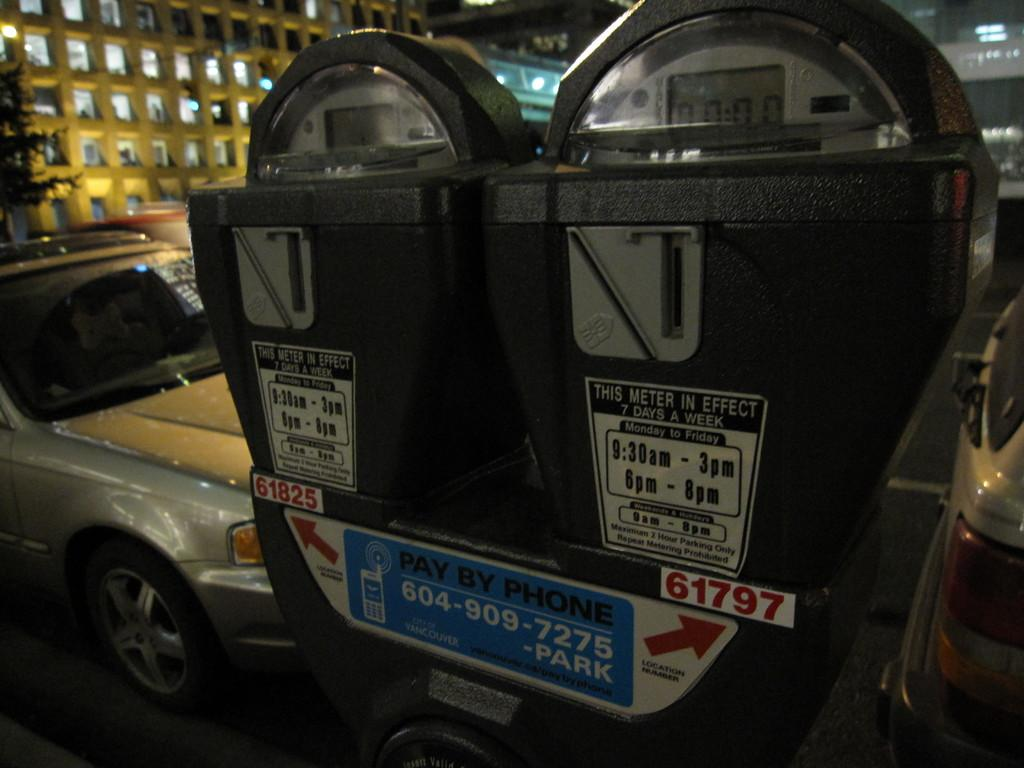<image>
Create a compact narrative representing the image presented. A parking meter that advertises PAY BY PHONE. 